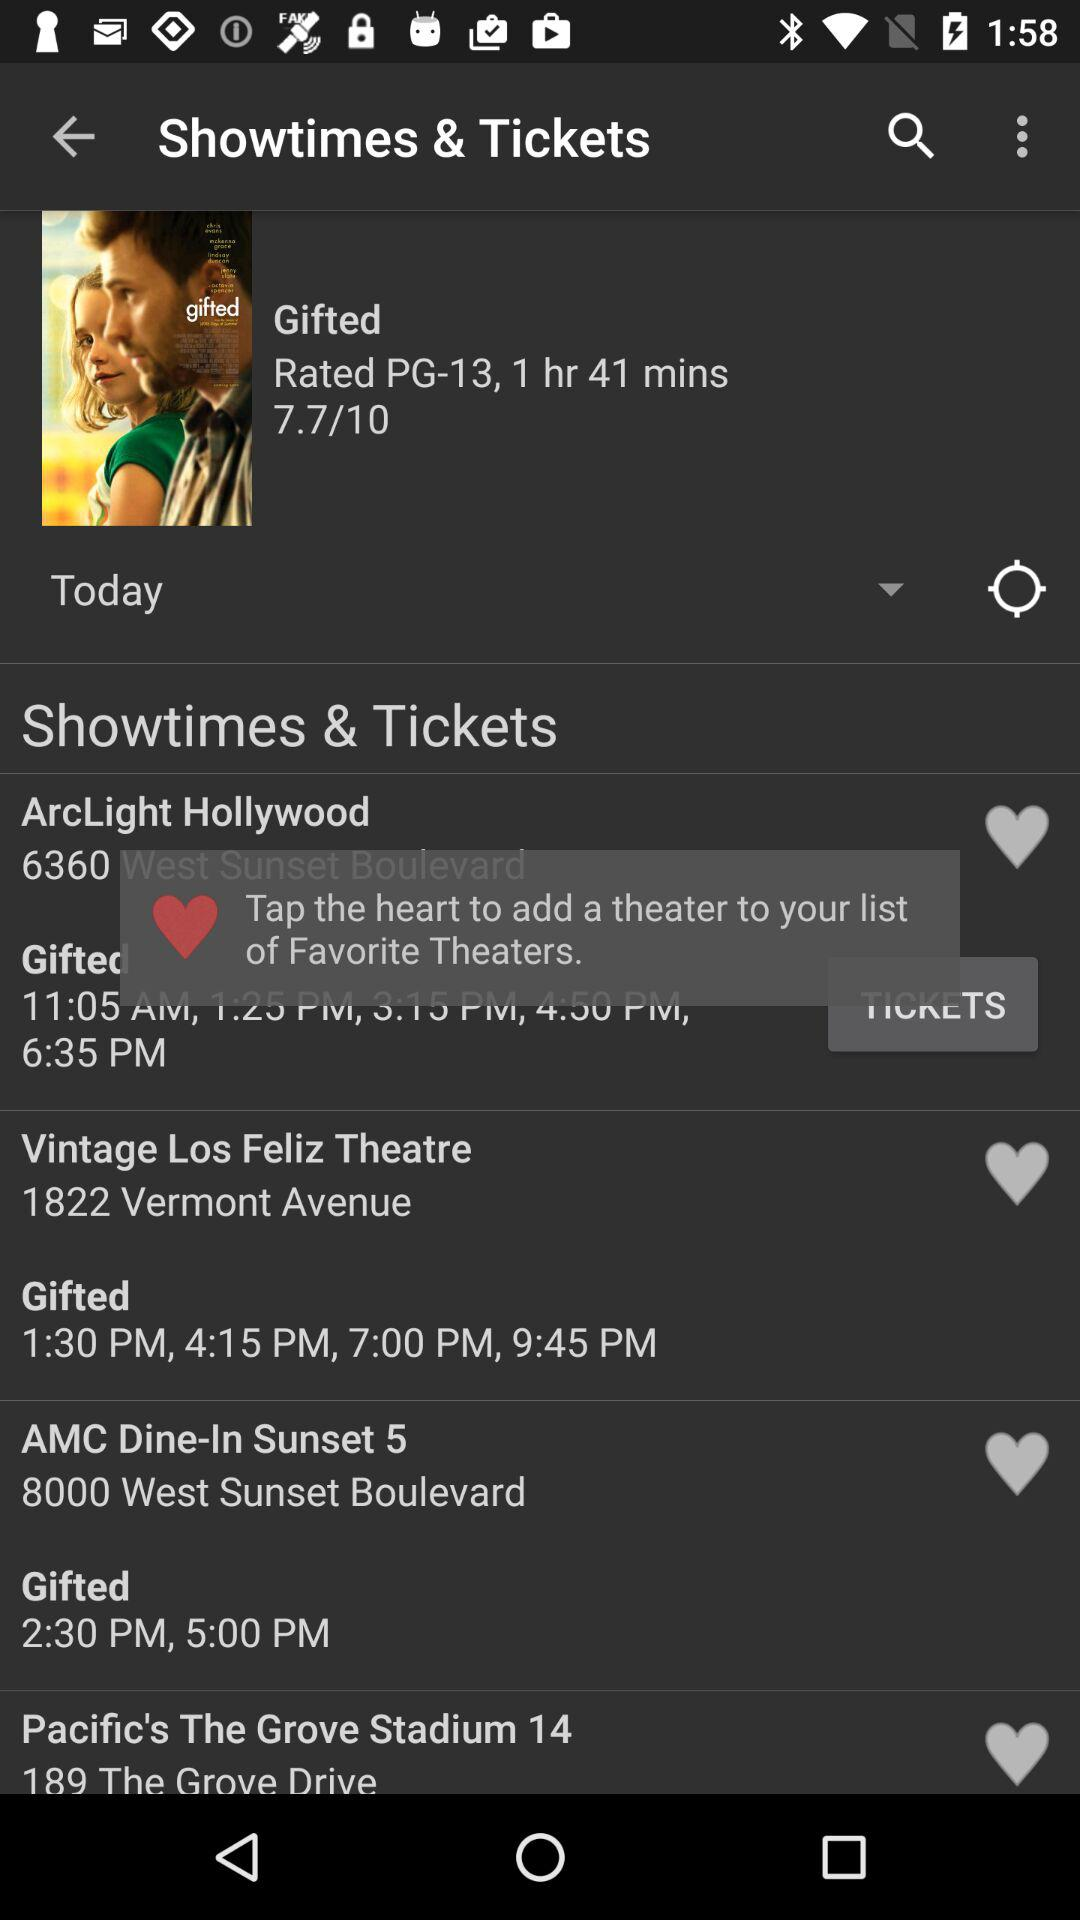What is the time duration of the movie? The time duration of the movie is 1 hour and 41 minutes. 